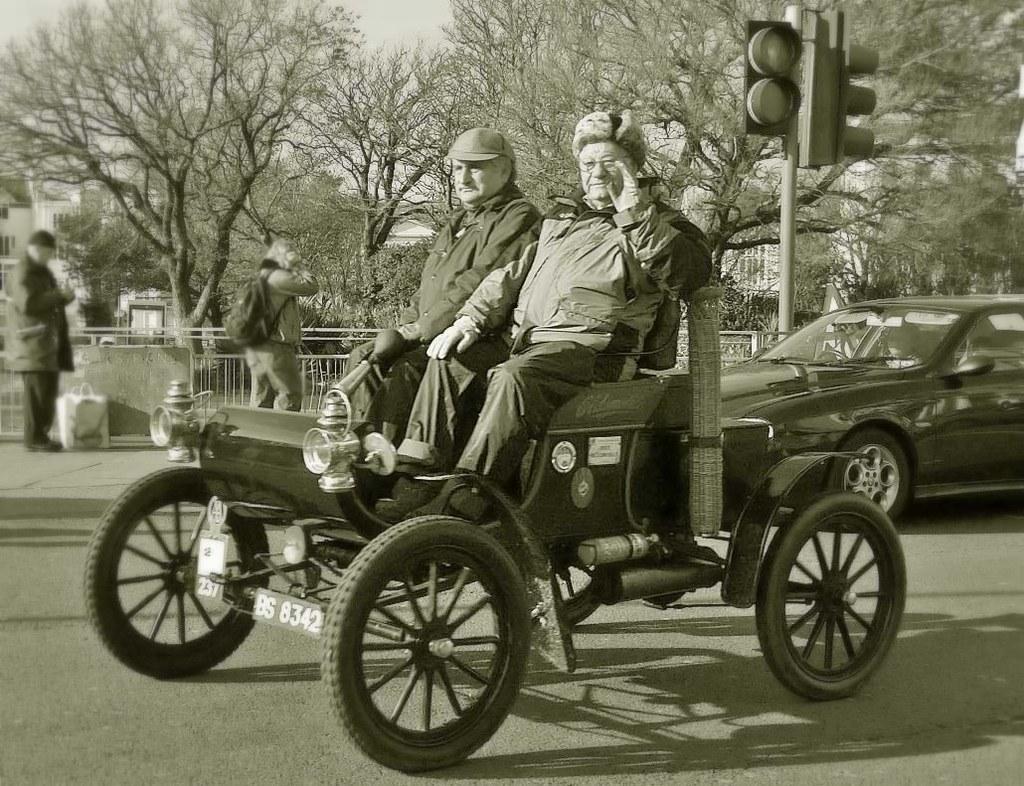Can you describe this image briefly? In this image there are two people sitting on an antique car are riding, behind them there is a car on the road, behind the car there is a traffic light and there are a few pedestrians walking on the pavement and there are some objects on the pavement. In the background of the image there are metal rod fence, trees and buildings. 